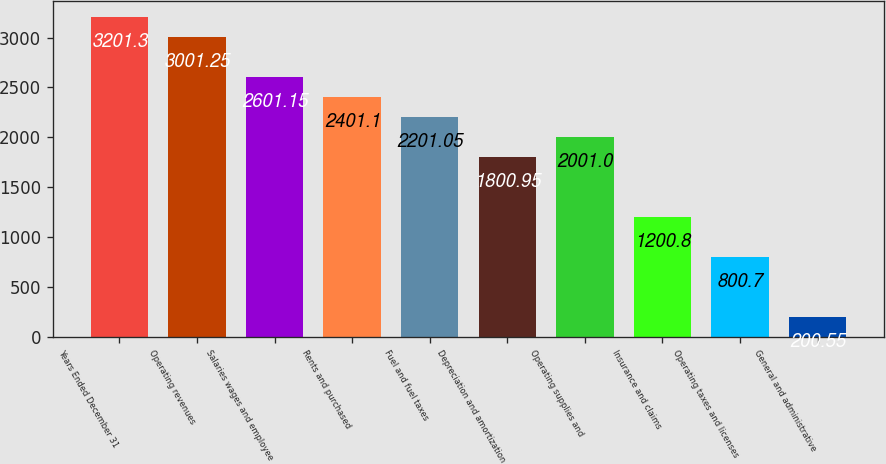Convert chart to OTSL. <chart><loc_0><loc_0><loc_500><loc_500><bar_chart><fcel>Years Ended December 31<fcel>Operating revenues<fcel>Salaries wages and employee<fcel>Rents and purchased<fcel>Fuel and fuel taxes<fcel>Depreciation and amortization<fcel>Operating supplies and<fcel>Insurance and claims<fcel>Operating taxes and licenses<fcel>General and administrative<nl><fcel>3201.3<fcel>3001.25<fcel>2601.15<fcel>2401.1<fcel>2201.05<fcel>1800.95<fcel>2001<fcel>1200.8<fcel>800.7<fcel>200.55<nl></chart> 